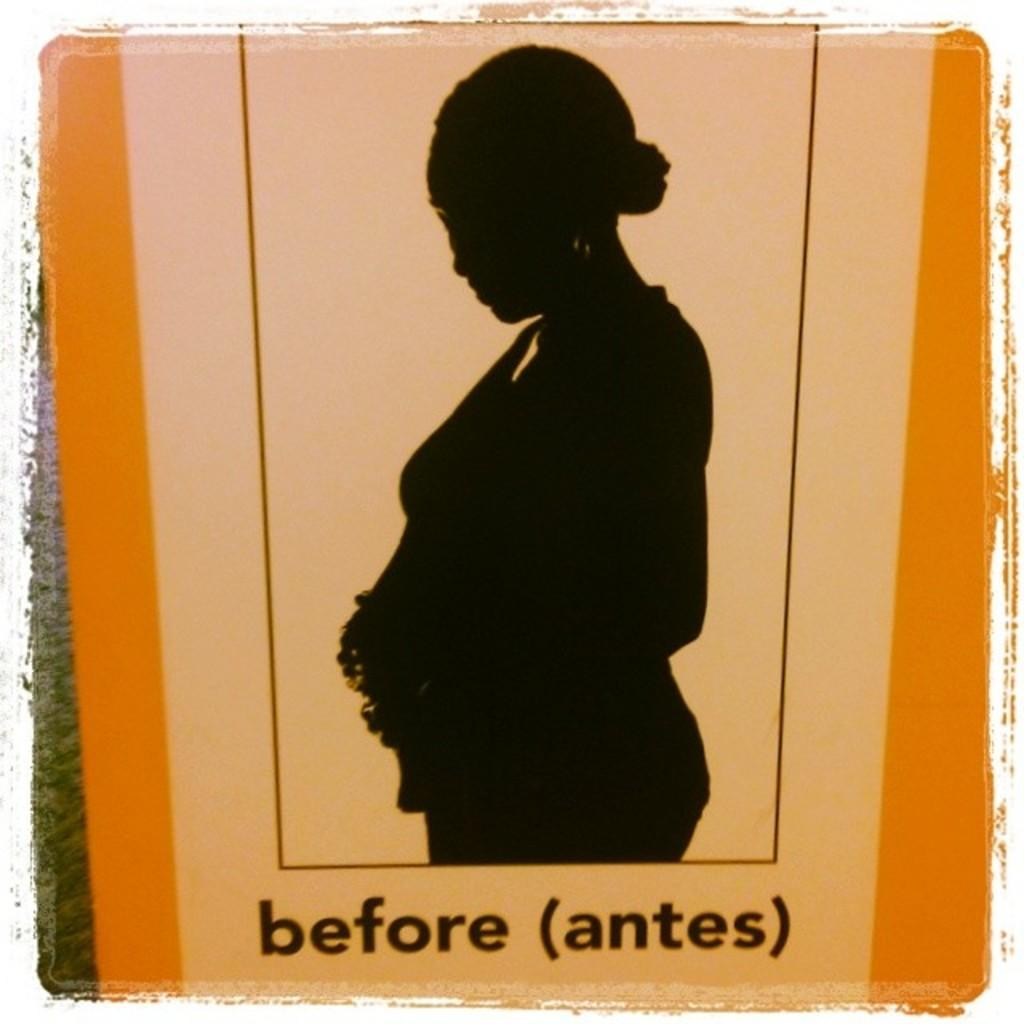What is the main object in the image? There is a board in the image. What is depicted on the board? There is a painting of a person on the board. Can you see the seashore in the background of the painting? A: There is no seashore visible in the image, as the focus is on the board and the painting of a person. 